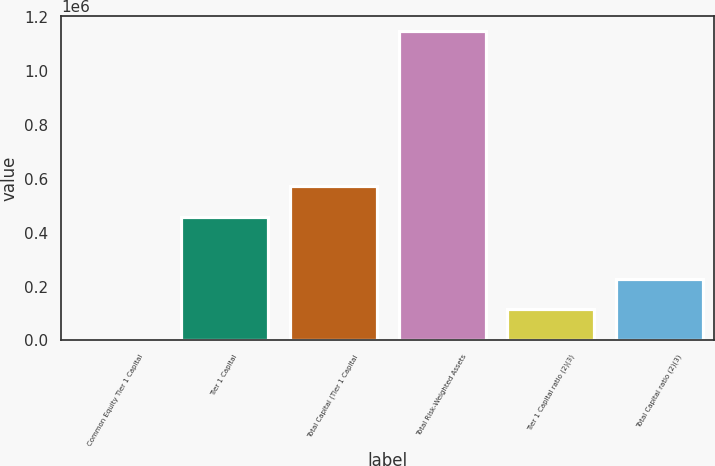Convert chart. <chart><loc_0><loc_0><loc_500><loc_500><bar_chart><fcel>Common Equity Tier 1 Capital<fcel>Tier 1 Capital<fcel>Total Capital (Tier 1 Capital<fcel>Total Risk-Weighted Assets<fcel>Tier 1 Capital ratio (2)(3)<fcel>Total Capital ratio (2)(3)<nl><fcel>13.02<fcel>459190<fcel>573985<fcel>1.14796e+06<fcel>114807<fcel>229602<nl></chart> 